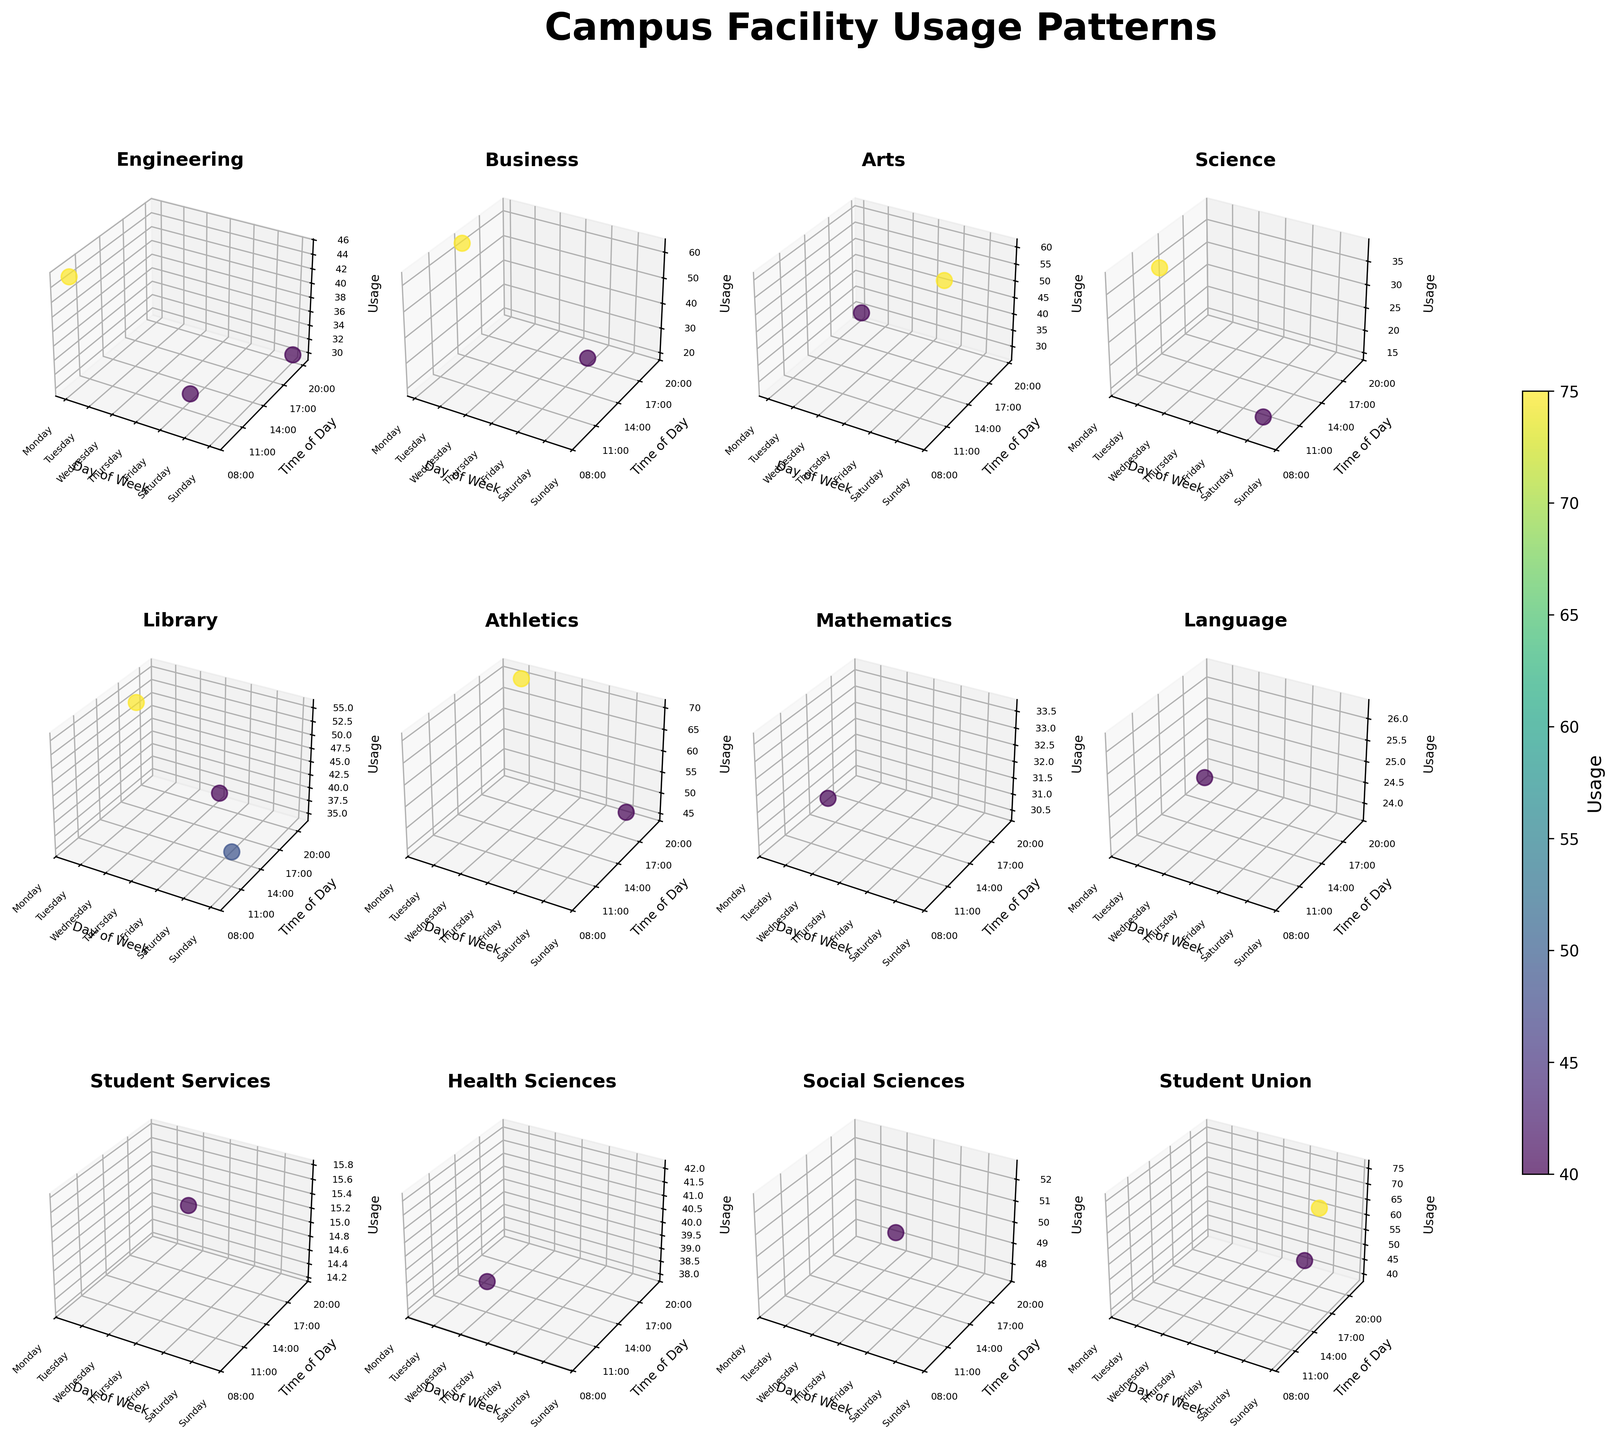What's the title of the figure? The title usually appears at the top of the figure. In this case, the title of the figure is 'Campus Facility Usage Patterns'.
Answer: Campus Facility Usage Patterns What does the color gradient represent in the figure? The color gradient typically indicates the value of the variable being measured. Here, the color gradient represents the usage levels of campus facilities, ranging from lower usage (lighter color) to higher usage (darker color).
Answer: Usage levels Which department has the highest facility usage, and at what time? Look for the department with the highest point on the z-axis and check the corresponding x and y values to identify the day and time. According to the figure, Athletics has the highest usage (Gym) on Tuesday at 19:00.
Answer: Athletics, Tuesday, 19:00 How often is the Engineering Computer Lab used during the week? The figure can be checked for all instances of the Engineering Computer Lab and count them. Engineering Computer Lab is used twice: once on Monday at 09:00 and once on Sunday at 20:00.
Answer: Twice Which day of the week shows the busiest facility usage for the Library, and what specific facility is it? Focus on the subplots for the Library and look for the days with the highest z-values. The busiest day for the Library is Tuesday, with the Group Study Rooms being the most used.
Answer: Tuesday, Group Study Rooms Compare the usage patterns of the Business department on Monday and Friday. Look at the Business subplot, find the z-values for Monday and Friday, and compare them. On Monday, the Study Hall is used at 14:00 with a usage of 62. On Friday, the Presentation Room is used at 17:00 with a usage of 20. Monday's usage is higher.
Answer: Monday's usage is higher What is the average usage level for facilities on Wednesday across all departments? Identify all data points for Wednesday, sum their z-values, and divide by the number of points. The usage levels for Wednesday are 32 (Mathematics), 25 (Language), and 15 (Student Services). The sum is 72, and there are 3 points, so the average is 72/3.
Answer: 24 Which facility in the Student Union has the highest usage, and at what time? Navigate to the Student Union subplot, and compare the z-values. The facility with the highest usage is the Dining Hall on Sunday at 15:00 with a usage of 75.
Answer: Dining Hall, Sunday, 15:00 What is the range of usage levels observed for the Science department through the week? In the Science subplot, find the highest and lowest points on the z-axis and calculate the range. The highest usage is the Chemistry Lab on Tuesday at 11:00 with 38, and the lowest is the Observatory on Saturday at 10:00 with 15. The range is 38 - 15.
Answer: 23 Which day has the lowest overall facility usage, and which department does it occur in? Check the lowest z-values across all subplots. The lowest is the Counseling Center from Student Services on Wednesday at 18:00 and has a usage of 15.
Answer: Wednesday, Student Services 